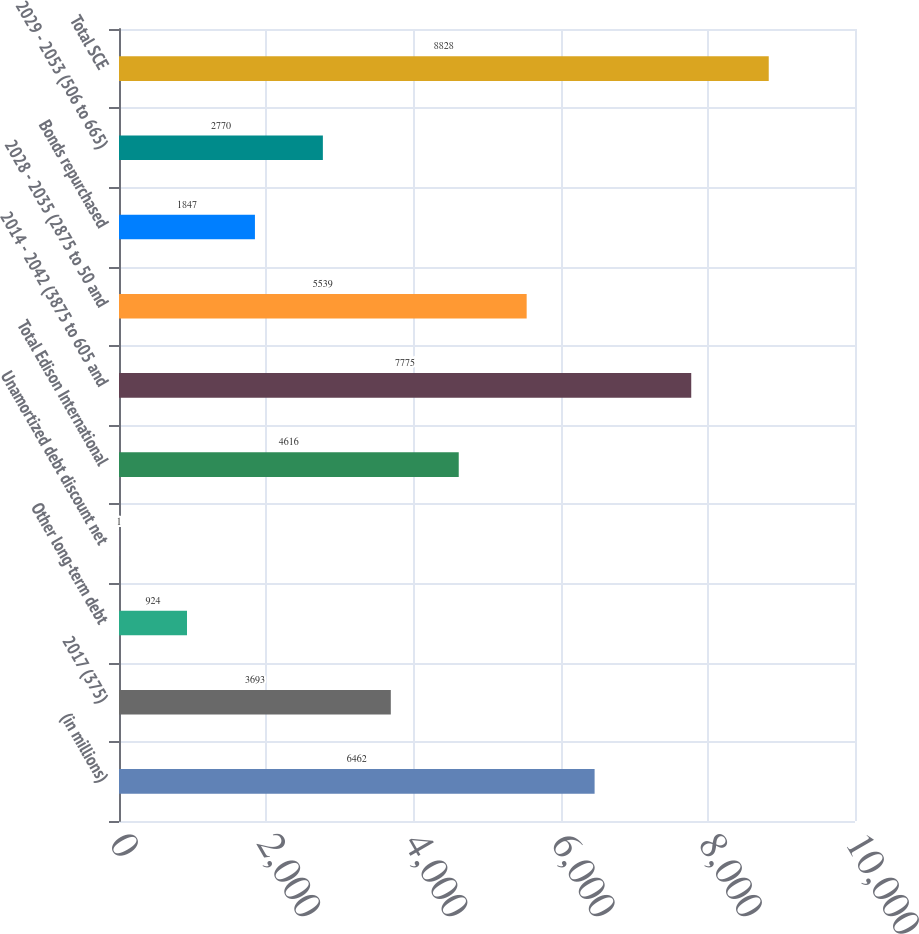Convert chart. <chart><loc_0><loc_0><loc_500><loc_500><bar_chart><fcel>(in millions)<fcel>2017 (375)<fcel>Other long-term debt<fcel>Unamortized debt discount net<fcel>Total Edison International<fcel>2014 - 2042 (3875 to 605 and<fcel>2028 - 2035 (2875 to 50 and<fcel>Bonds repurchased<fcel>2029 - 2053 (506 to 665)<fcel>Total SCE<nl><fcel>6462<fcel>3693<fcel>924<fcel>1<fcel>4616<fcel>7775<fcel>5539<fcel>1847<fcel>2770<fcel>8828<nl></chart> 